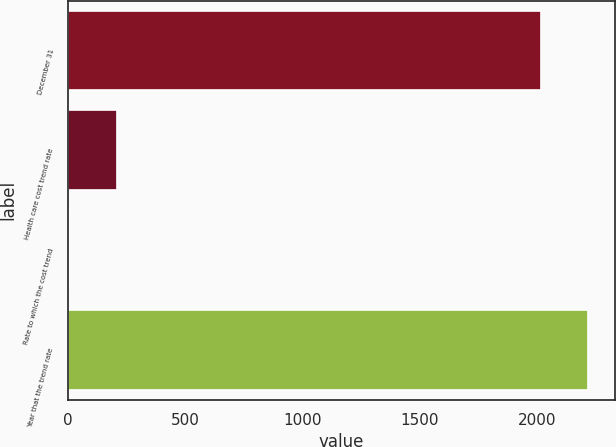Convert chart to OTSL. <chart><loc_0><loc_0><loc_500><loc_500><bar_chart><fcel>December 31<fcel>Health care cost trend rate<fcel>Rate to which the cost trend<fcel>Year that the trend rate<nl><fcel>2016<fcel>207.25<fcel>4.5<fcel>2218.75<nl></chart> 